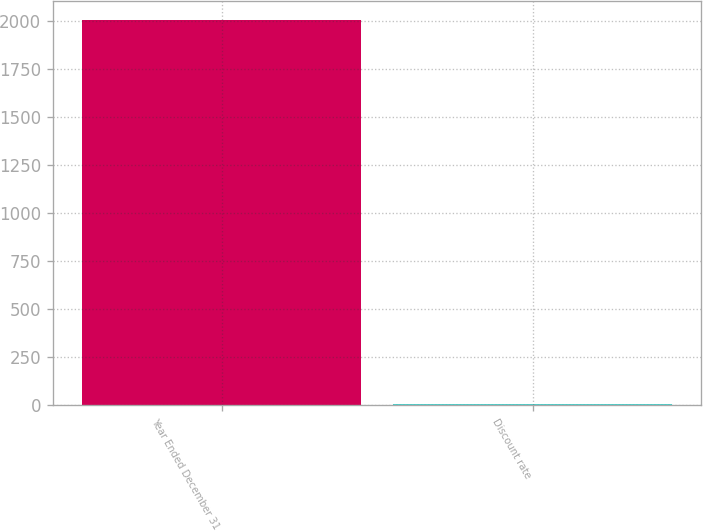<chart> <loc_0><loc_0><loc_500><loc_500><bar_chart><fcel>Year Ended December 31<fcel>Discount rate<nl><fcel>2008<fcel>6<nl></chart> 